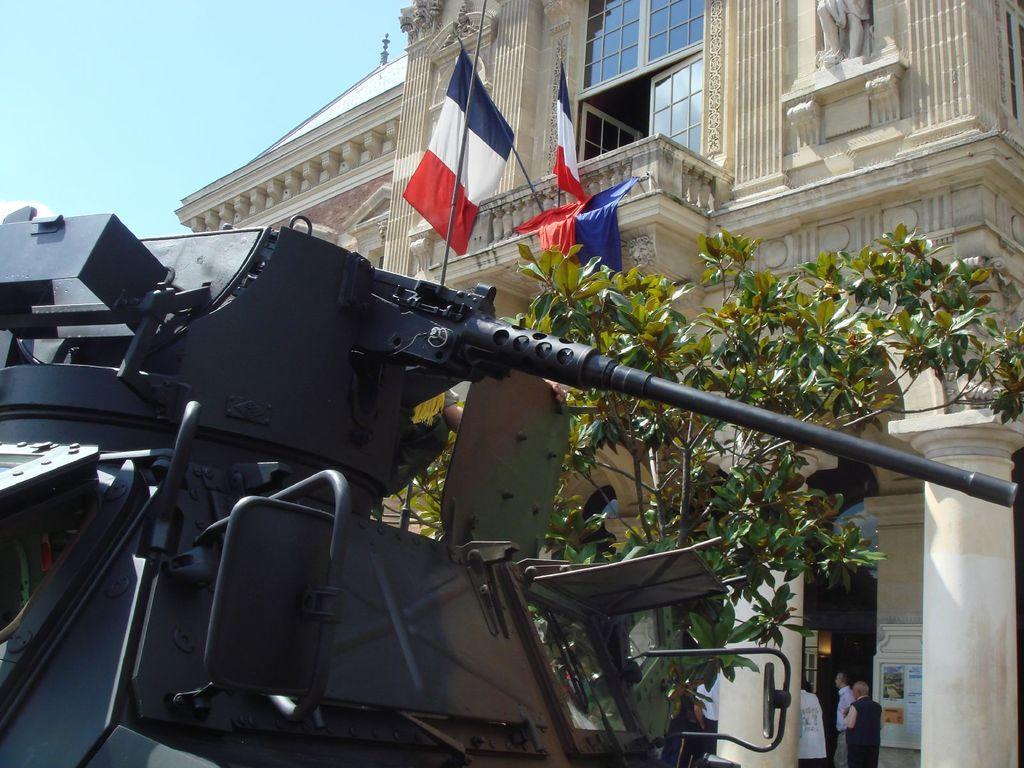How would you summarize this image in a sentence or two? There is a machine gun on the left side of this image, and we can see some people and a tree on the right side of this image. There is a building in the background. There are flags on the building as we can see in the middle of this image. There is a sky at the top of this image. 